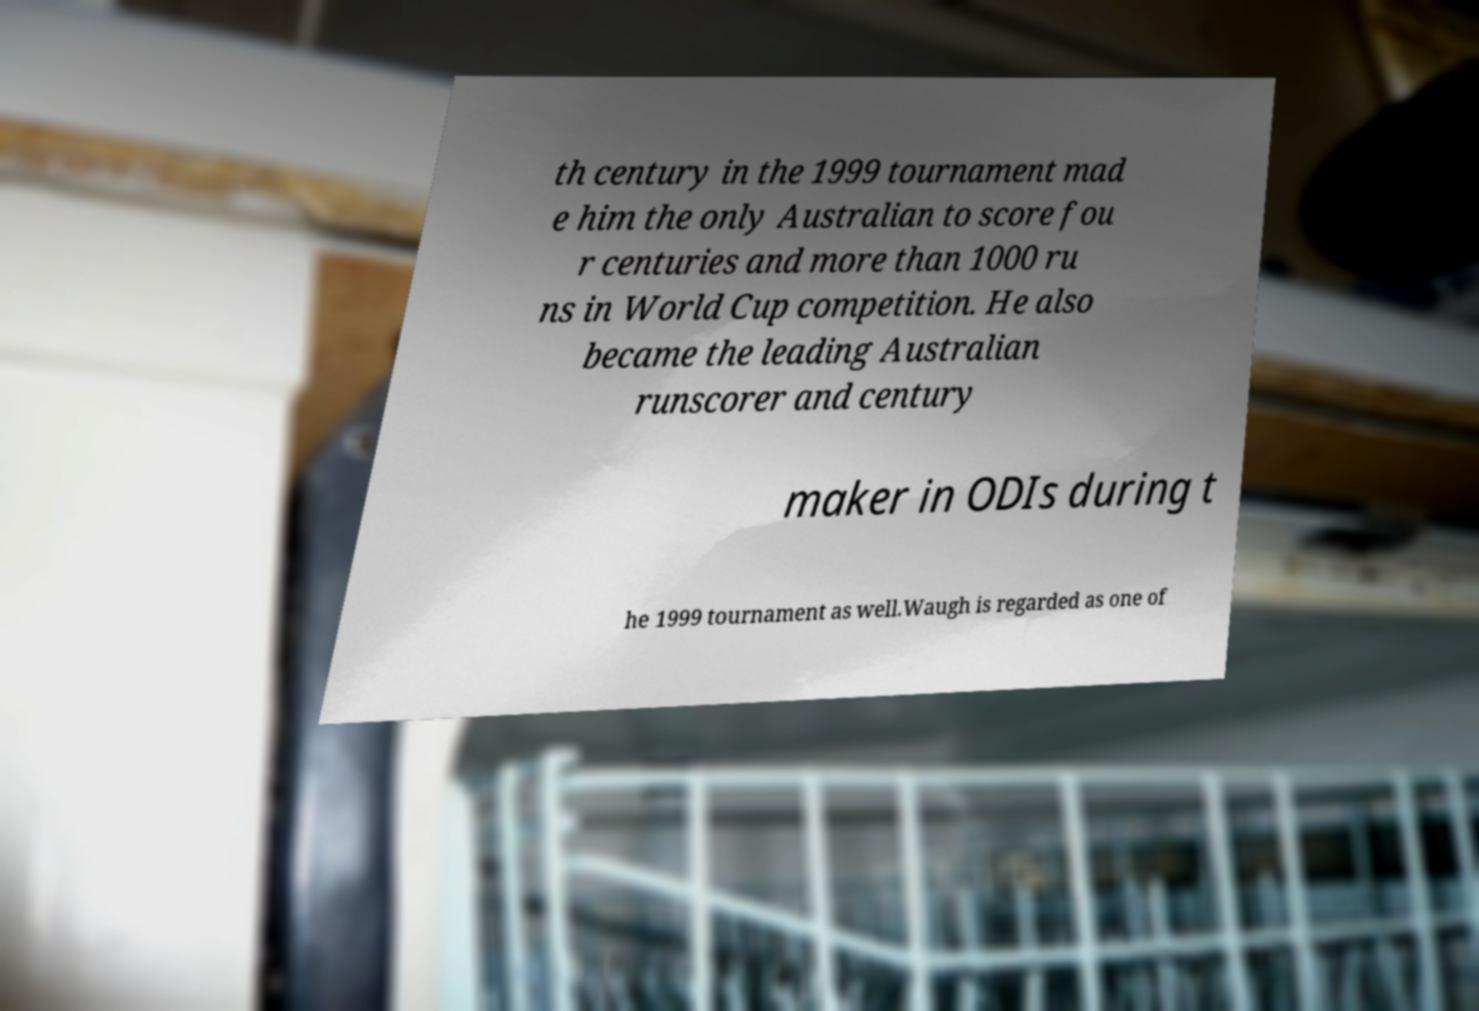I need the written content from this picture converted into text. Can you do that? th century in the 1999 tournament mad e him the only Australian to score fou r centuries and more than 1000 ru ns in World Cup competition. He also became the leading Australian runscorer and century maker in ODIs during t he 1999 tournament as well.Waugh is regarded as one of 